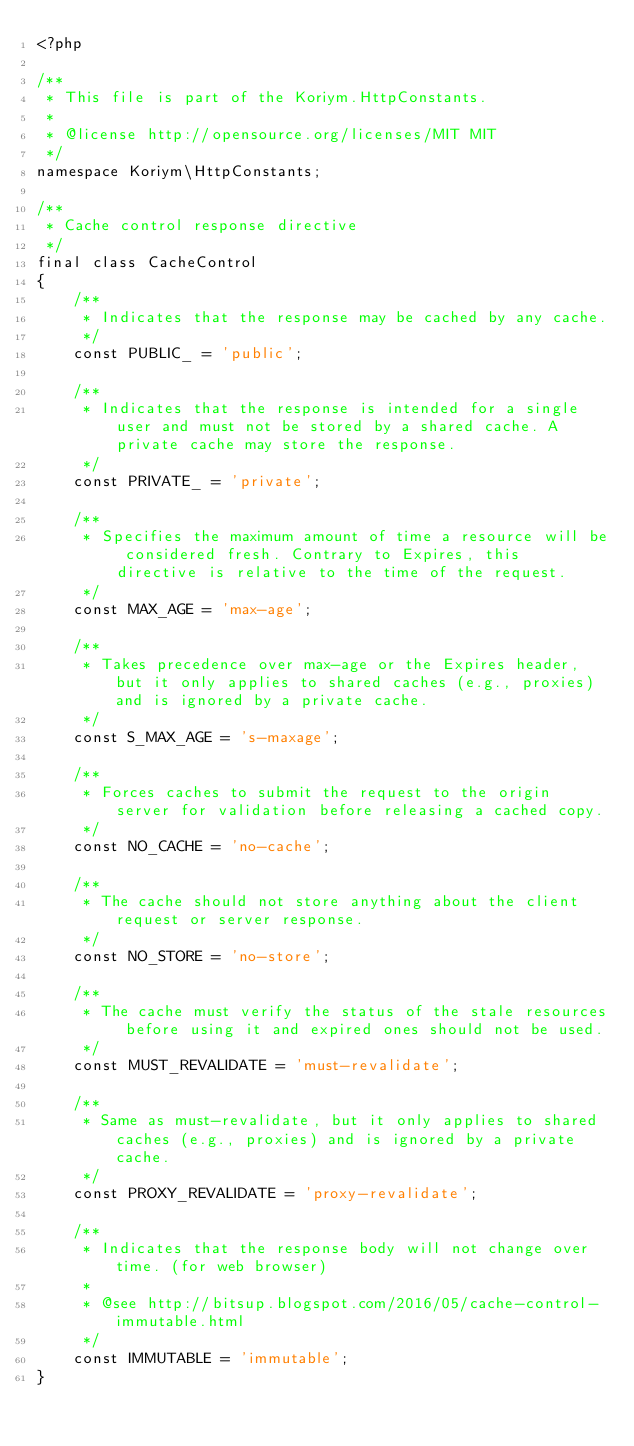Convert code to text. <code><loc_0><loc_0><loc_500><loc_500><_PHP_><?php

/**
 * This file is part of the Koriym.HttpConstants.
 *
 * @license http://opensource.org/licenses/MIT MIT
 */
namespace Koriym\HttpConstants;

/**
 * Cache control response directive
 */
final class CacheControl
{
    /**
     * Indicates that the response may be cached by any cache.
     */
    const PUBLIC_ = 'public';

    /**
     * Indicates that the response is intended for a single user and must not be stored by a shared cache. A private cache may store the response.
     */
    const PRIVATE_ = 'private';

    /**
     * Specifies the maximum amount of time a resource will be considered fresh. Contrary to Expires, this directive is relative to the time of the request.
     */
    const MAX_AGE = 'max-age';

    /**
     * Takes precedence over max-age or the Expires header, but it only applies to shared caches (e.g., proxies) and is ignored by a private cache.
     */
    const S_MAX_AGE = 's-maxage';

    /**
     * Forces caches to submit the request to the origin server for validation before releasing a cached copy.
     */
    const NO_CACHE = 'no-cache';

    /**
     * The cache should not store anything about the client request or server response.
     */
    const NO_STORE = 'no-store';

    /**
     * The cache must verify the status of the stale resources before using it and expired ones should not be used.
     */
    const MUST_REVALIDATE = 'must-revalidate';

    /**
     * Same as must-revalidate, but it only applies to shared caches (e.g., proxies) and is ignored by a private cache.
     */
    const PROXY_REVALIDATE = 'proxy-revalidate';

    /**
     * Indicates that the response body will not change over time. (for web browser)
     *
     * @see http://bitsup.blogspot.com/2016/05/cache-control-immutable.html
     */
    const IMMUTABLE = 'immutable';
}
</code> 